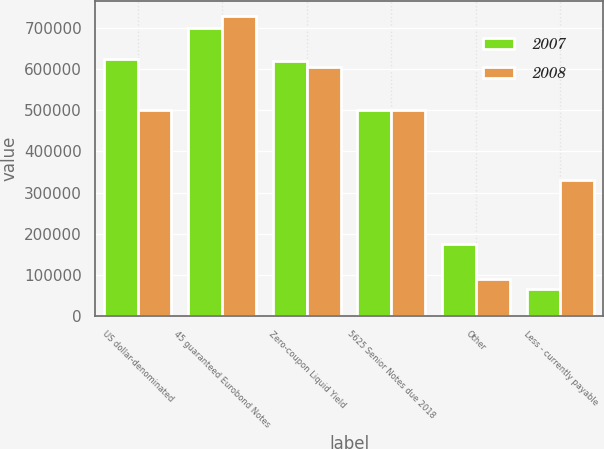Convert chart. <chart><loc_0><loc_0><loc_500><loc_500><stacked_bar_chart><ecel><fcel>US dollar-denominated<fcel>45 guaranteed Eurobond Notes<fcel>Zero-coupon Liquid Yield<fcel>5625 Senior Notes due 2018<fcel>Other<fcel>Less - currently payable<nl><fcel>2007<fcel>623728<fcel>699400<fcel>619757<fcel>500000<fcel>176444<fcel>66159<nl><fcel>2008<fcel>500000<fcel>729600<fcel>605938<fcel>500000<fcel>89780<fcel>330480<nl></chart> 